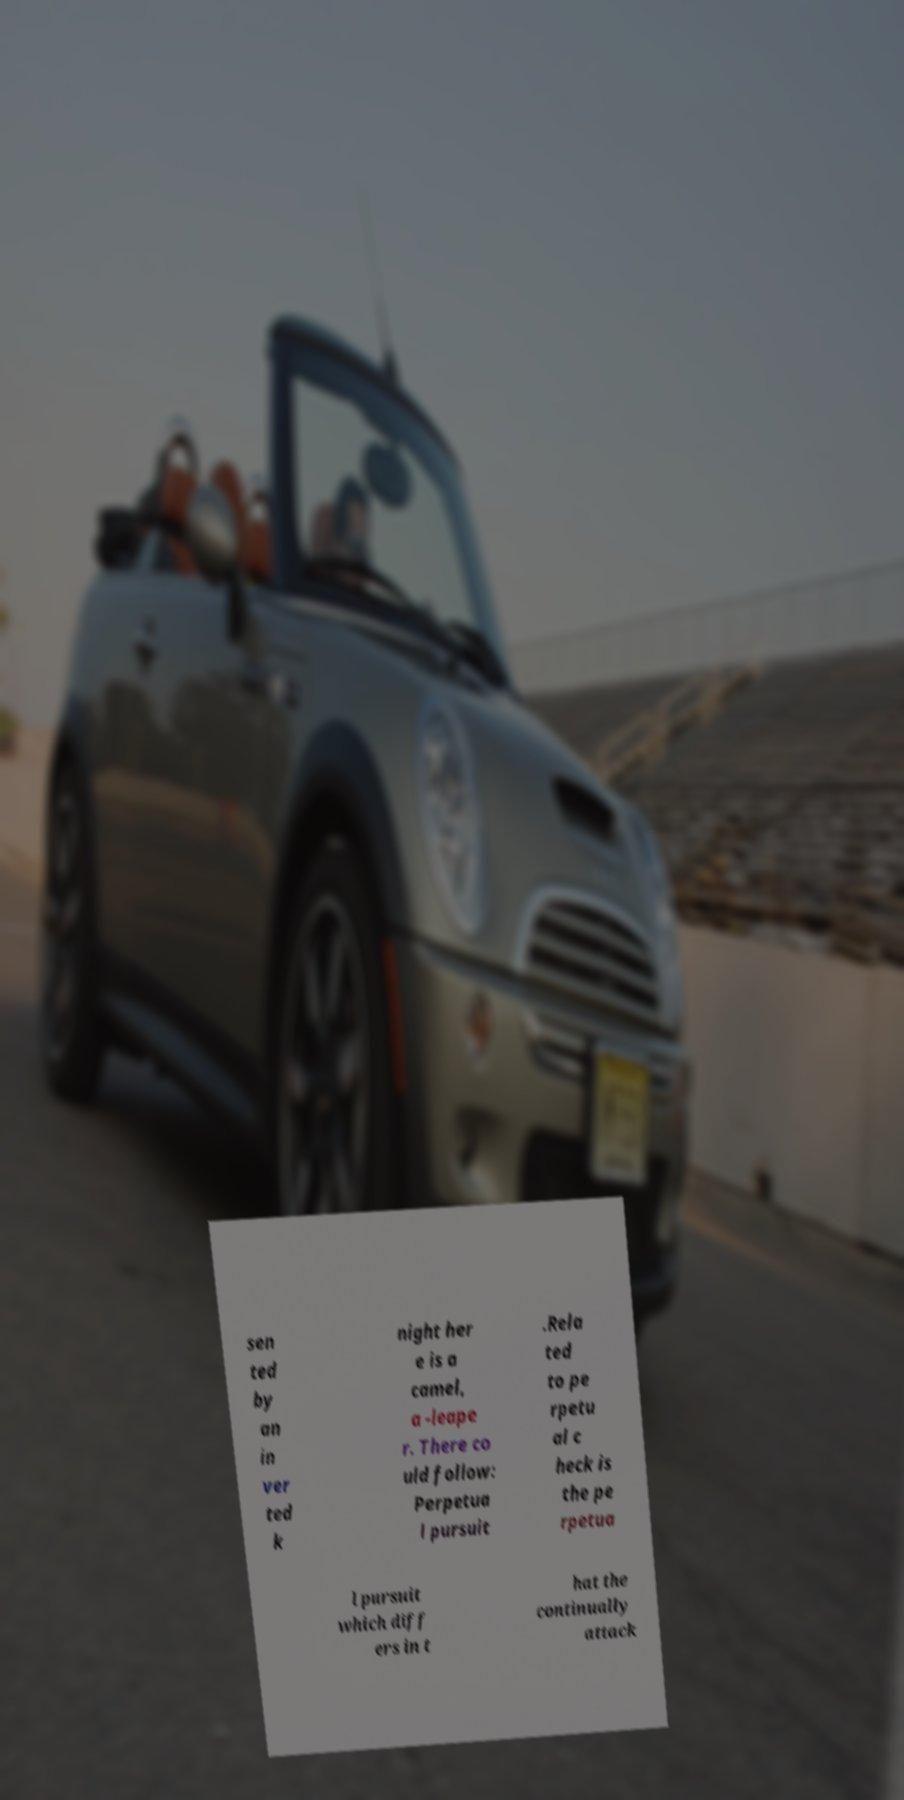Please read and relay the text visible in this image. What does it say? sen ted by an in ver ted k night her e is a camel, a -leape r. There co uld follow: Perpetua l pursuit .Rela ted to pe rpetu al c heck is the pe rpetua l pursuit which diff ers in t hat the continually attack 